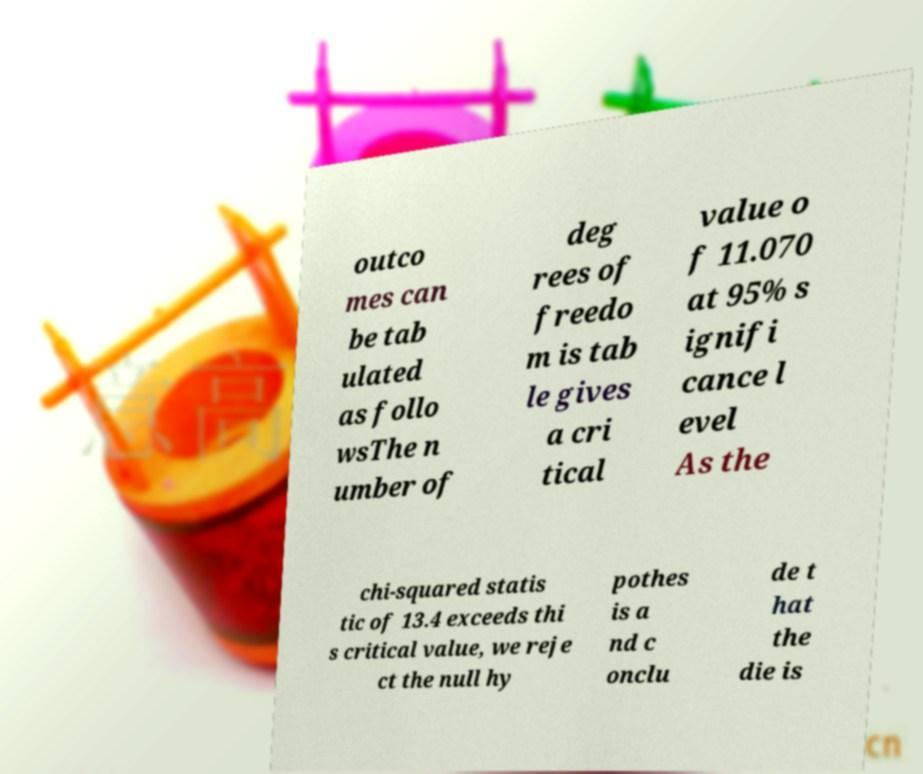There's text embedded in this image that I need extracted. Can you transcribe it verbatim? outco mes can be tab ulated as follo wsThe n umber of deg rees of freedo m is tab le gives a cri tical value o f 11.070 at 95% s ignifi cance l evel As the chi-squared statis tic of 13.4 exceeds thi s critical value, we reje ct the null hy pothes is a nd c onclu de t hat the die is 